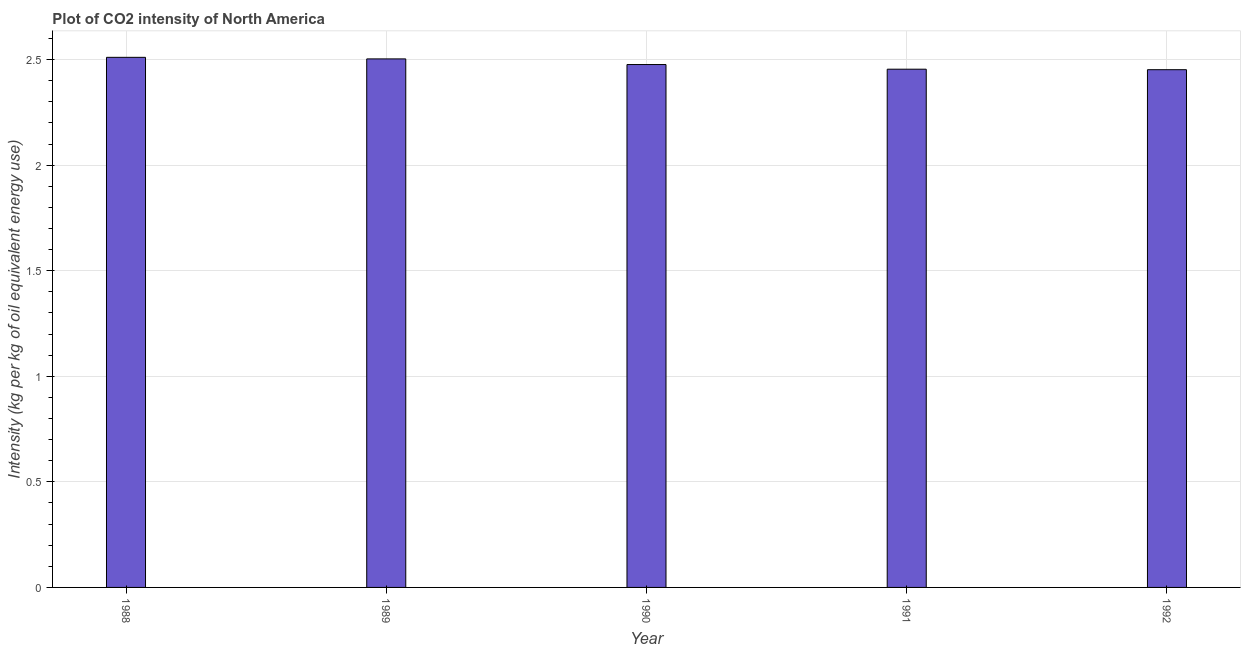What is the title of the graph?
Offer a terse response. Plot of CO2 intensity of North America. What is the label or title of the Y-axis?
Ensure brevity in your answer.  Intensity (kg per kg of oil equivalent energy use). What is the co2 intensity in 1990?
Make the answer very short. 2.48. Across all years, what is the maximum co2 intensity?
Provide a succinct answer. 2.51. Across all years, what is the minimum co2 intensity?
Give a very brief answer. 2.45. What is the sum of the co2 intensity?
Offer a very short reply. 12.4. What is the difference between the co2 intensity in 1988 and 1992?
Provide a succinct answer. 0.06. What is the average co2 intensity per year?
Your response must be concise. 2.48. What is the median co2 intensity?
Your answer should be very brief. 2.48. Do a majority of the years between 1988 and 1989 (inclusive) have co2 intensity greater than 0.4 kg?
Your response must be concise. Yes. What is the ratio of the co2 intensity in 1988 to that in 1989?
Offer a terse response. 1. Is the co2 intensity in 1989 less than that in 1992?
Your answer should be compact. No. What is the difference between the highest and the second highest co2 intensity?
Ensure brevity in your answer.  0.01. Is the sum of the co2 intensity in 1988 and 1989 greater than the maximum co2 intensity across all years?
Ensure brevity in your answer.  Yes. Are the values on the major ticks of Y-axis written in scientific E-notation?
Your answer should be compact. No. What is the Intensity (kg per kg of oil equivalent energy use) in 1988?
Make the answer very short. 2.51. What is the Intensity (kg per kg of oil equivalent energy use) of 1989?
Make the answer very short. 2.5. What is the Intensity (kg per kg of oil equivalent energy use) in 1990?
Offer a terse response. 2.48. What is the Intensity (kg per kg of oil equivalent energy use) of 1991?
Provide a short and direct response. 2.45. What is the Intensity (kg per kg of oil equivalent energy use) of 1992?
Make the answer very short. 2.45. What is the difference between the Intensity (kg per kg of oil equivalent energy use) in 1988 and 1989?
Your answer should be compact. 0.01. What is the difference between the Intensity (kg per kg of oil equivalent energy use) in 1988 and 1990?
Your answer should be very brief. 0.03. What is the difference between the Intensity (kg per kg of oil equivalent energy use) in 1988 and 1991?
Give a very brief answer. 0.06. What is the difference between the Intensity (kg per kg of oil equivalent energy use) in 1988 and 1992?
Offer a terse response. 0.06. What is the difference between the Intensity (kg per kg of oil equivalent energy use) in 1989 and 1990?
Offer a very short reply. 0.03. What is the difference between the Intensity (kg per kg of oil equivalent energy use) in 1989 and 1991?
Your response must be concise. 0.05. What is the difference between the Intensity (kg per kg of oil equivalent energy use) in 1989 and 1992?
Offer a terse response. 0.05. What is the difference between the Intensity (kg per kg of oil equivalent energy use) in 1990 and 1991?
Offer a terse response. 0.02. What is the difference between the Intensity (kg per kg of oil equivalent energy use) in 1990 and 1992?
Ensure brevity in your answer.  0.02. What is the difference between the Intensity (kg per kg of oil equivalent energy use) in 1991 and 1992?
Offer a terse response. 0. What is the ratio of the Intensity (kg per kg of oil equivalent energy use) in 1988 to that in 1989?
Keep it short and to the point. 1. What is the ratio of the Intensity (kg per kg of oil equivalent energy use) in 1988 to that in 1990?
Offer a very short reply. 1.01. What is the ratio of the Intensity (kg per kg of oil equivalent energy use) in 1988 to that in 1991?
Offer a very short reply. 1.02. What is the ratio of the Intensity (kg per kg of oil equivalent energy use) in 1988 to that in 1992?
Your answer should be very brief. 1.02. What is the ratio of the Intensity (kg per kg of oil equivalent energy use) in 1990 to that in 1992?
Ensure brevity in your answer.  1.01. 